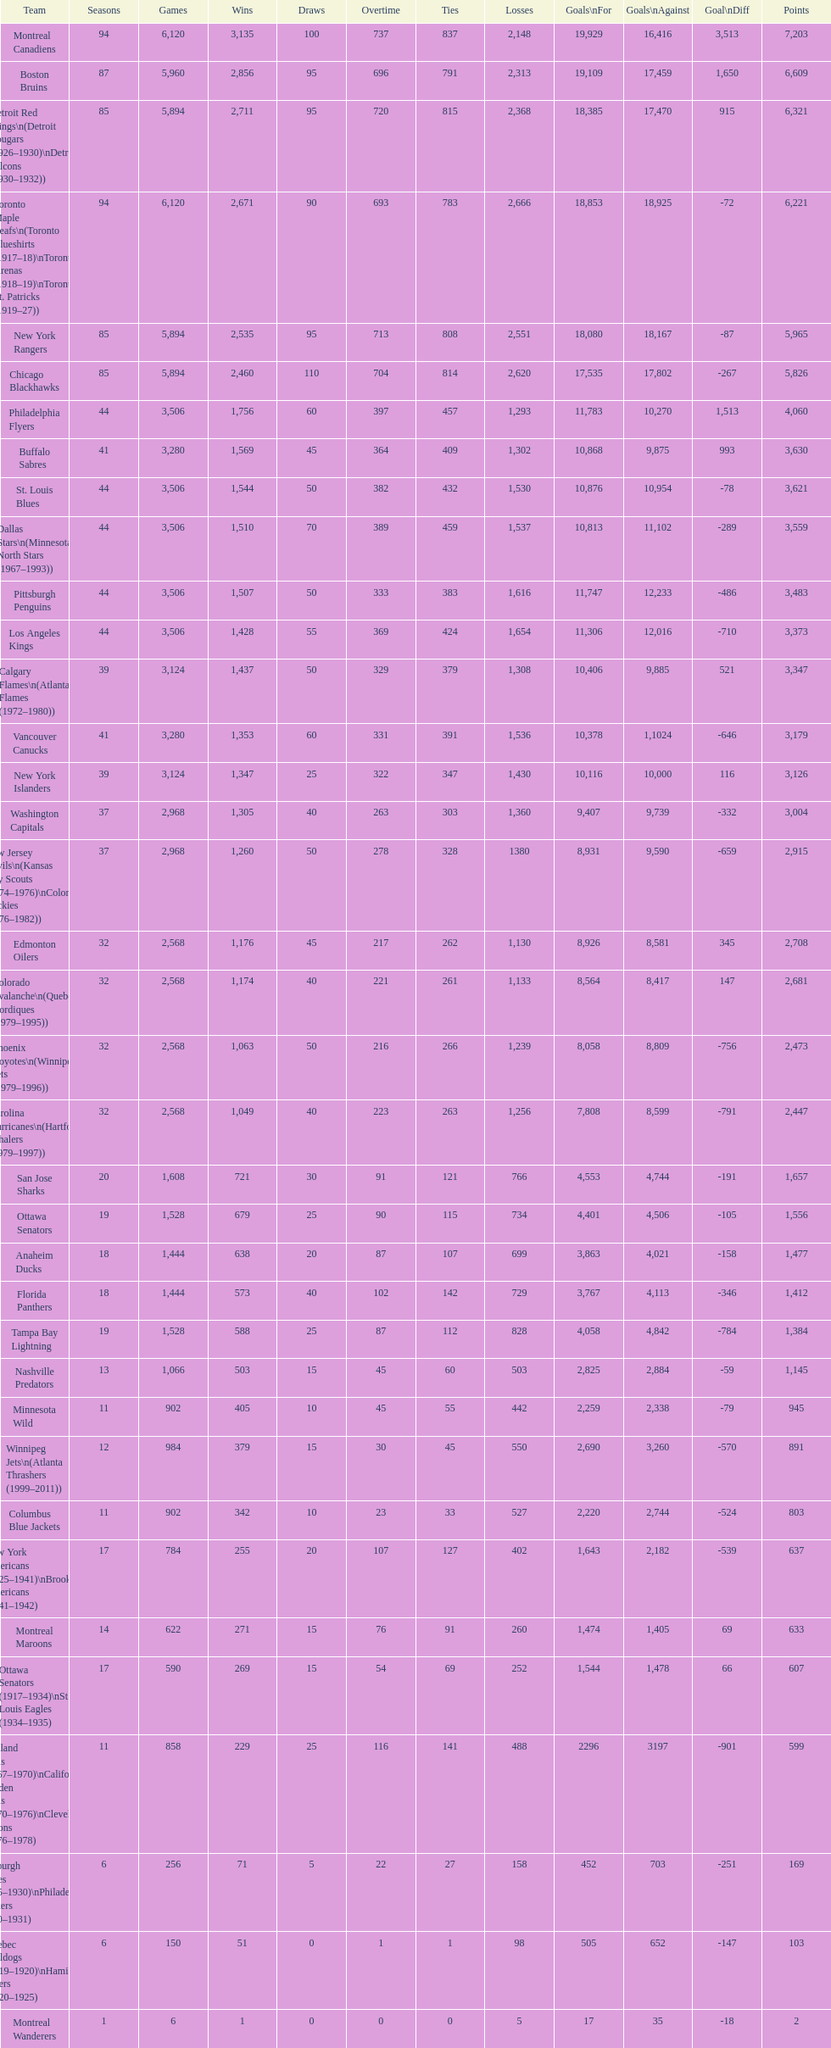Which team played the same amount of seasons as the canadiens? Toronto Maple Leafs. Can you give me this table as a dict? {'header': ['Team', 'Seasons', 'Games', 'Wins', 'Draws', 'Overtime', 'Ties', 'Losses', 'Goals\\nFor', 'Goals\\nAgainst', 'Goal\\nDiff', 'Points'], 'rows': [['Montreal Canadiens', '94', '6,120', '3,135', '100', '737', '837', '2,148', '19,929', '16,416', '3,513', '7,203'], ['Boston Bruins', '87', '5,960', '2,856', '95', '696', '791', '2,313', '19,109', '17,459', '1,650', '6,609'], ['Detroit Red Wings\\n(Detroit Cougars (1926–1930)\\nDetroit Falcons (1930–1932))', '85', '5,894', '2,711', '95', '720', '815', '2,368', '18,385', '17,470', '915', '6,321'], ['Toronto Maple Leafs\\n(Toronto Blueshirts (1917–18)\\nToronto Arenas (1918–19)\\nToronto St. Patricks (1919–27))', '94', '6,120', '2,671', '90', '693', '783', '2,666', '18,853', '18,925', '-72', '6,221'], ['New York Rangers', '85', '5,894', '2,535', '95', '713', '808', '2,551', '18,080', '18,167', '-87', '5,965'], ['Chicago Blackhawks', '85', '5,894', '2,460', '110', '704', '814', '2,620', '17,535', '17,802', '-267', '5,826'], ['Philadelphia Flyers', '44', '3,506', '1,756', '60', '397', '457', '1,293', '11,783', '10,270', '1,513', '4,060'], ['Buffalo Sabres', '41', '3,280', '1,569', '45', '364', '409', '1,302', '10,868', '9,875', '993', '3,630'], ['St. Louis Blues', '44', '3,506', '1,544', '50', '382', '432', '1,530', '10,876', '10,954', '-78', '3,621'], ['Dallas Stars\\n(Minnesota North Stars (1967–1993))', '44', '3,506', '1,510', '70', '389', '459', '1,537', '10,813', '11,102', '-289', '3,559'], ['Pittsburgh Penguins', '44', '3,506', '1,507', '50', '333', '383', '1,616', '11,747', '12,233', '-486', '3,483'], ['Los Angeles Kings', '44', '3,506', '1,428', '55', '369', '424', '1,654', '11,306', '12,016', '-710', '3,373'], ['Calgary Flames\\n(Atlanta Flames (1972–1980))', '39', '3,124', '1,437', '50', '329', '379', '1,308', '10,406', '9,885', '521', '3,347'], ['Vancouver Canucks', '41', '3,280', '1,353', '60', '331', '391', '1,536', '10,378', '1,1024', '-646', '3,179'], ['New York Islanders', '39', '3,124', '1,347', '25', '322', '347', '1,430', '10,116', '10,000', '116', '3,126'], ['Washington Capitals', '37', '2,968', '1,305', '40', '263', '303', '1,360', '9,407', '9,739', '-332', '3,004'], ['New Jersey Devils\\n(Kansas City Scouts (1974–1976)\\nColorado Rockies (1976–1982))', '37', '2,968', '1,260', '50', '278', '328', '1380', '8,931', '9,590', '-659', '2,915'], ['Edmonton Oilers', '32', '2,568', '1,176', '45', '217', '262', '1,130', '8,926', '8,581', '345', '2,708'], ['Colorado Avalanche\\n(Quebec Nordiques (1979–1995))', '32', '2,568', '1,174', '40', '221', '261', '1,133', '8,564', '8,417', '147', '2,681'], ['Phoenix Coyotes\\n(Winnipeg Jets (1979–1996))', '32', '2,568', '1,063', '50', '216', '266', '1,239', '8,058', '8,809', '-756', '2,473'], ['Carolina Hurricanes\\n(Hartford Whalers (1979–1997))', '32', '2,568', '1,049', '40', '223', '263', '1,256', '7,808', '8,599', '-791', '2,447'], ['San Jose Sharks', '20', '1,608', '721', '30', '91', '121', '766', '4,553', '4,744', '-191', '1,657'], ['Ottawa Senators', '19', '1,528', '679', '25', '90', '115', '734', '4,401', '4,506', '-105', '1,556'], ['Anaheim Ducks', '18', '1,444', '638', '20', '87', '107', '699', '3,863', '4,021', '-158', '1,477'], ['Florida Panthers', '18', '1,444', '573', '40', '102', '142', '729', '3,767', '4,113', '-346', '1,412'], ['Tampa Bay Lightning', '19', '1,528', '588', '25', '87', '112', '828', '4,058', '4,842', '-784', '1,384'], ['Nashville Predators', '13', '1,066', '503', '15', '45', '60', '503', '2,825', '2,884', '-59', '1,145'], ['Minnesota Wild', '11', '902', '405', '10', '45', '55', '442', '2,259', '2,338', '-79', '945'], ['Winnipeg Jets\\n(Atlanta Thrashers (1999–2011))', '12', '984', '379', '15', '30', '45', '550', '2,690', '3,260', '-570', '891'], ['Columbus Blue Jackets', '11', '902', '342', '10', '23', '33', '527', '2,220', '2,744', '-524', '803'], ['New York Americans (1925–1941)\\nBrooklyn Americans (1941–1942)', '17', '784', '255', '20', '107', '127', '402', '1,643', '2,182', '-539', '637'], ['Montreal Maroons', '14', '622', '271', '15', '76', '91', '260', '1,474', '1,405', '69', '633'], ['Ottawa Senators (1917–1934)\\nSt. Louis Eagles (1934–1935)', '17', '590', '269', '15', '54', '69', '252', '1,544', '1,478', '66', '607'], ['Oakland Seals (1967–1970)\\nCalifornia Golden Seals (1970–1976)\\nCleveland Barons (1976–1978)', '11', '858', '229', '25', '116', '141', '488', '2296', '3197', '-901', '599'], ['Pittsburgh Pirates (1925–1930)\\nPhiladelphia Quakers (1930–1931)', '6', '256', '71', '5', '22', '27', '158', '452', '703', '-251', '169'], ['Quebec Bulldogs (1919–1920)\\nHamilton Tigers (1920–1925)', '6', '150', '51', '0', '1', '1', '98', '505', '652', '-147', '103'], ['Montreal Wanderers', '1', '6', '1', '0', '0', '0', '5', '17', '35', '-18', '2']]} 